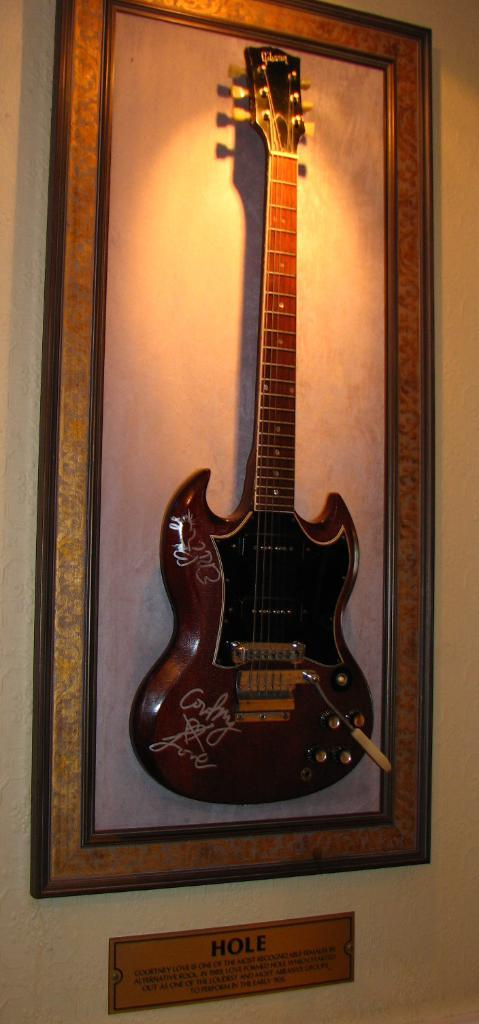<image>
Provide a brief description of the given image. An electric guitar displayed on the wall with a sign that says HOLE. 